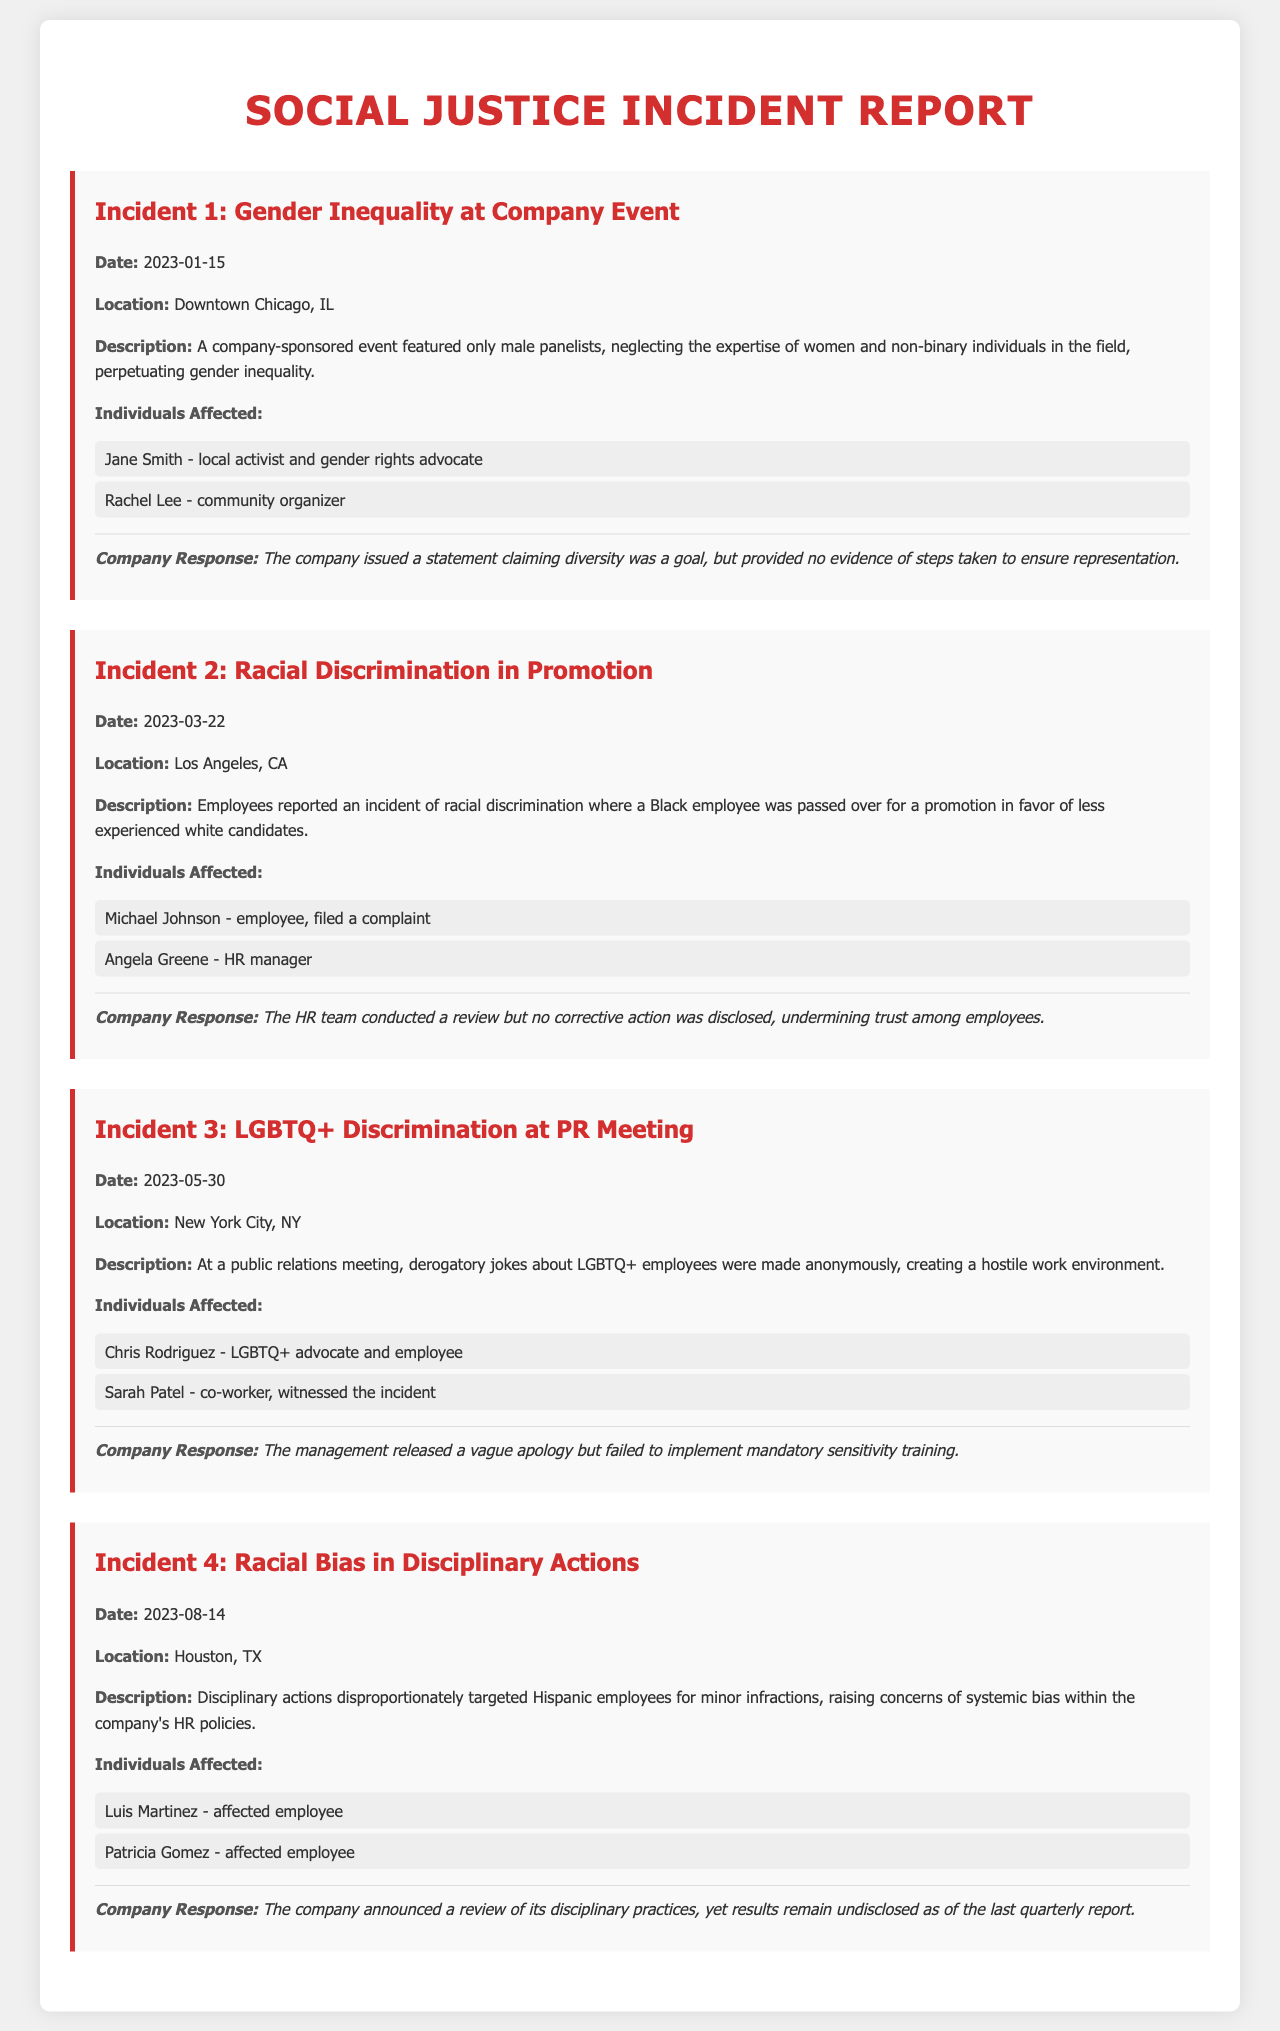What is the date of the gender inequality incident? The date of the gender inequality incident is specified in the document under Incident 1.
Answer: 2023-01-15 Who was the affected employee in the racial discrimination promotion incident? The document lists the affected employee under Incident 2.
Answer: Michael Johnson How many incidents of discrimination are reported in the document? The total number of incidents is counted from the different incident sections in the document.
Answer: 4 What location is associated with the LGBTQ+ discrimination incident? The document provides the specific location of the LGBTQ+ discrimination incident under Incident 3.
Answer: New York City, NY What response did the company give for the racial bias in disciplinary actions? The response given by the company is detailed under Incident 4.
Answer: A review of its disciplinary practices What was the reason for the derogatory jokes made during the PR meeting? The document describes the content of the jokes during the incident under Incident 3.
Answer: Creating a hostile work environment What is the name of the community organizer affected by the gender inequality incident? This information can be found in the affected individuals' list under Incident 1.
Answer: Rachel Lee What issues were disproportionately targeted in the racial bias incident? The document mentions specific infractions that were targeted under Incident 4.
Answer: Minor infractions What did the company fail to implement after the LGBTQ+ discrimination incident? This failure is highlighted as part of the company response in Incident 3.
Answer: Mandatory sensitivity training 